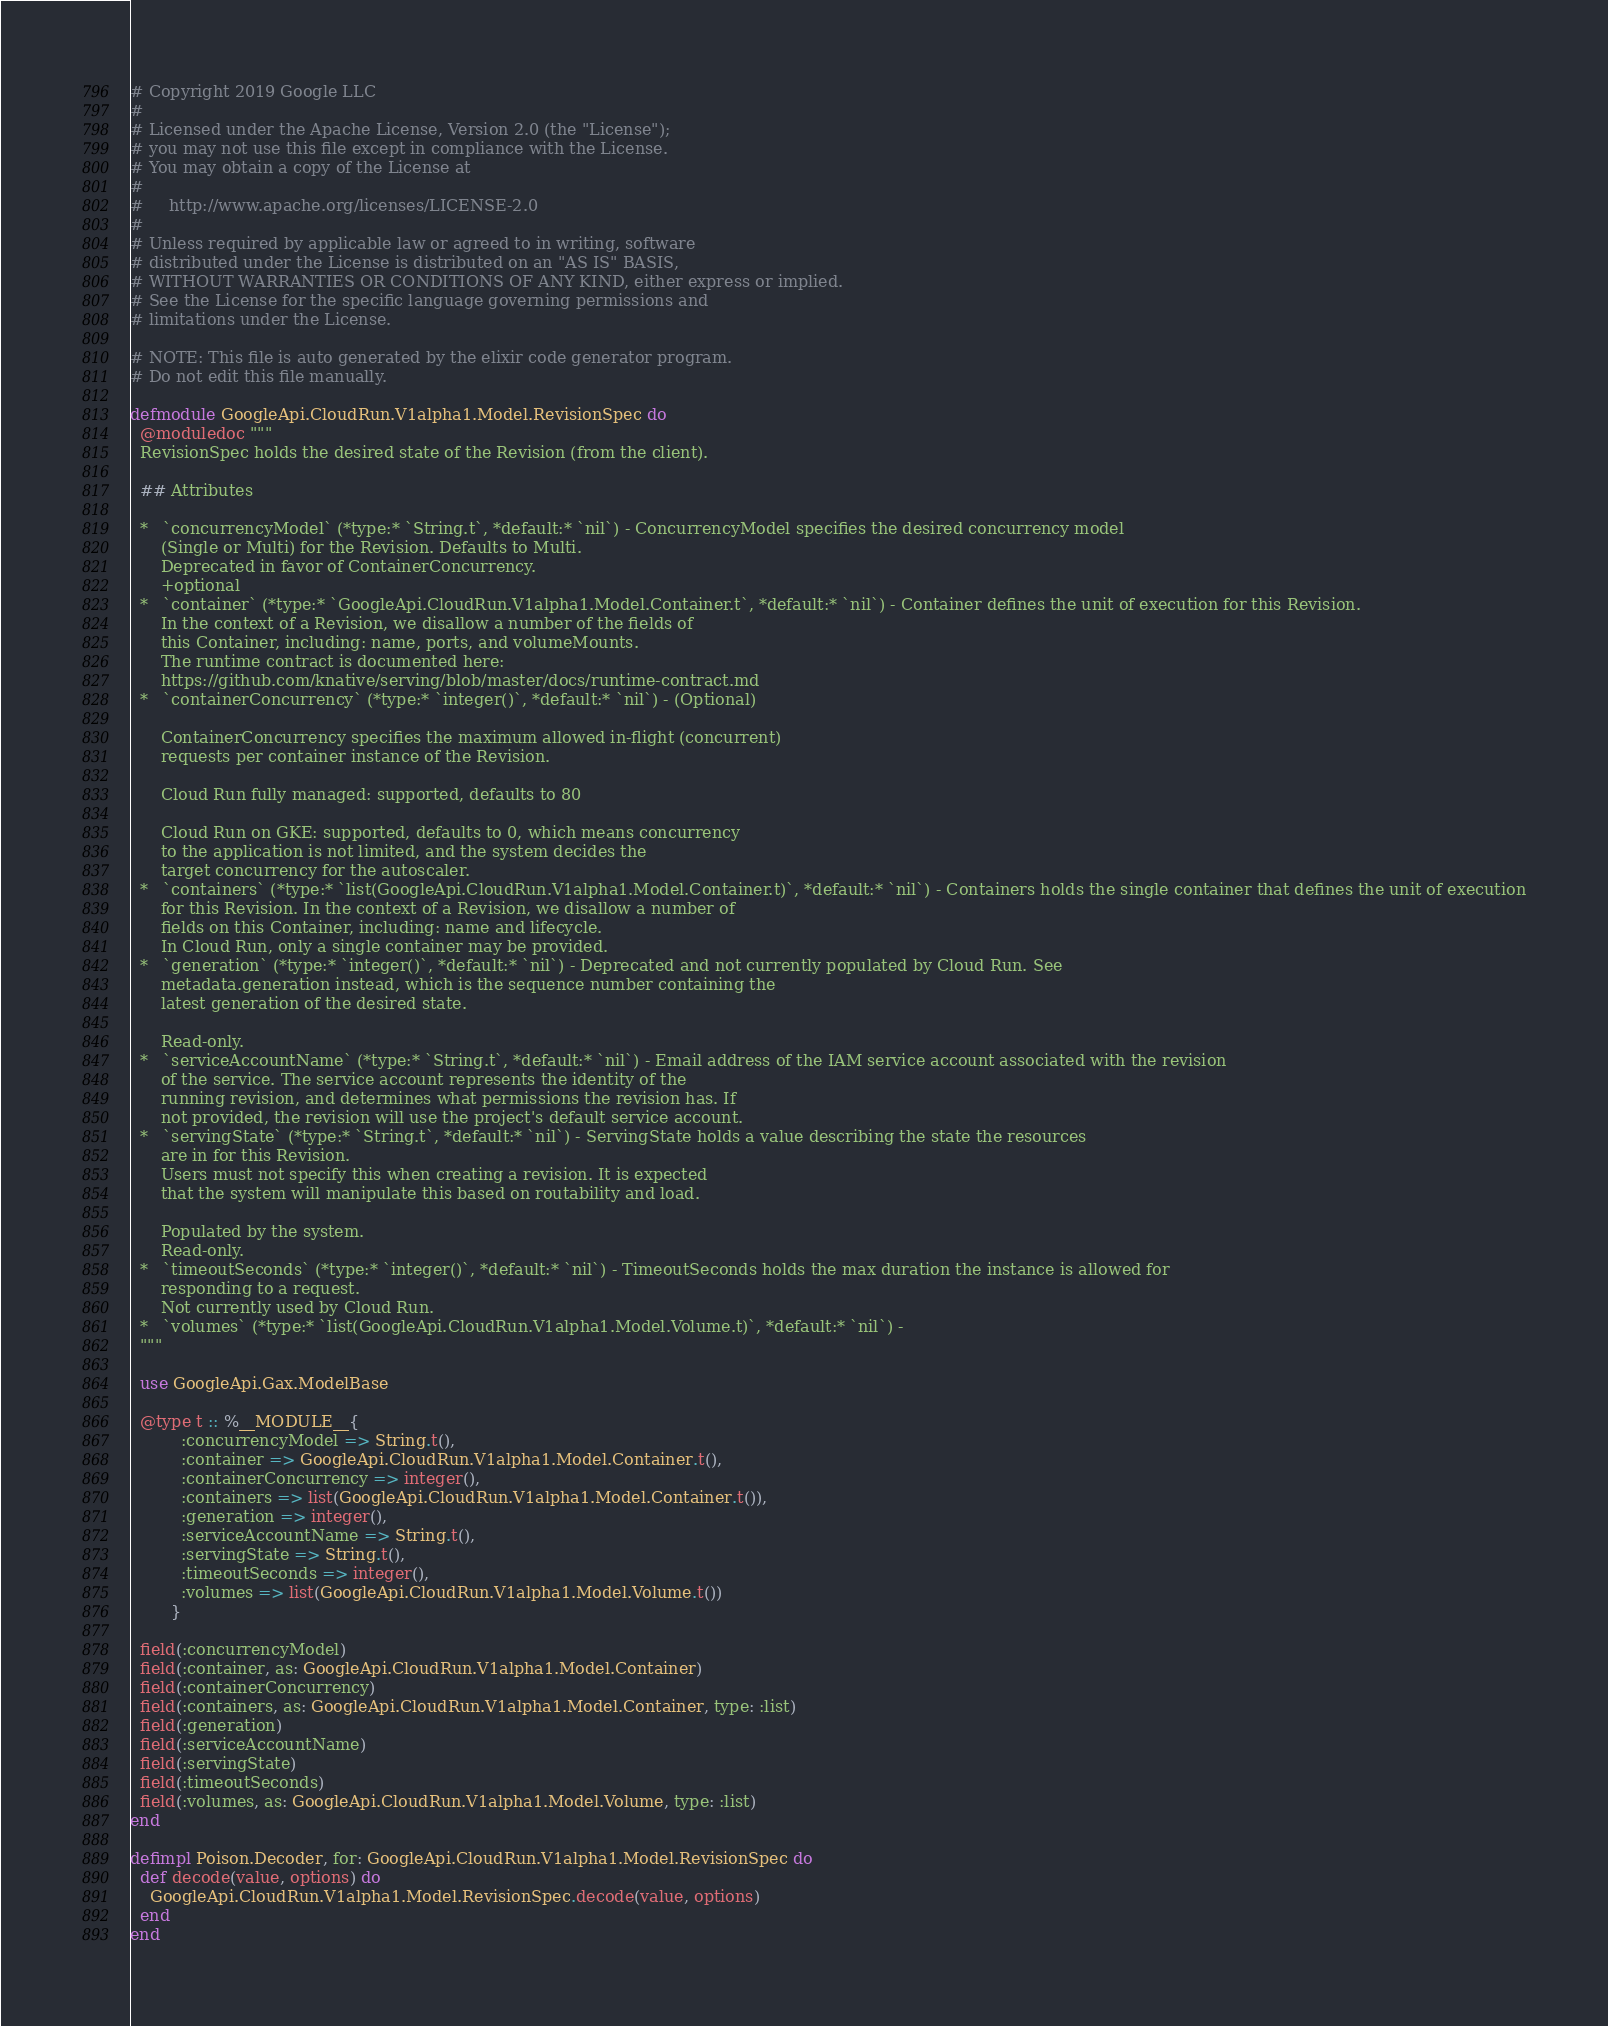Convert code to text. <code><loc_0><loc_0><loc_500><loc_500><_Elixir_># Copyright 2019 Google LLC
#
# Licensed under the Apache License, Version 2.0 (the "License");
# you may not use this file except in compliance with the License.
# You may obtain a copy of the License at
#
#     http://www.apache.org/licenses/LICENSE-2.0
#
# Unless required by applicable law or agreed to in writing, software
# distributed under the License is distributed on an "AS IS" BASIS,
# WITHOUT WARRANTIES OR CONDITIONS OF ANY KIND, either express or implied.
# See the License for the specific language governing permissions and
# limitations under the License.

# NOTE: This file is auto generated by the elixir code generator program.
# Do not edit this file manually.

defmodule GoogleApi.CloudRun.V1alpha1.Model.RevisionSpec do
  @moduledoc """
  RevisionSpec holds the desired state of the Revision (from the client).

  ## Attributes

  *   `concurrencyModel` (*type:* `String.t`, *default:* `nil`) - ConcurrencyModel specifies the desired concurrency model
      (Single or Multi) for the Revision. Defaults to Multi.
      Deprecated in favor of ContainerConcurrency.
      +optional
  *   `container` (*type:* `GoogleApi.CloudRun.V1alpha1.Model.Container.t`, *default:* `nil`) - Container defines the unit of execution for this Revision.
      In the context of a Revision, we disallow a number of the fields of
      this Container, including: name, ports, and volumeMounts.
      The runtime contract is documented here:
      https://github.com/knative/serving/blob/master/docs/runtime-contract.md
  *   `containerConcurrency` (*type:* `integer()`, *default:* `nil`) - (Optional)

      ContainerConcurrency specifies the maximum allowed in-flight (concurrent)
      requests per container instance of the Revision.

      Cloud Run fully managed: supported, defaults to 80

      Cloud Run on GKE: supported, defaults to 0, which means concurrency
      to the application is not limited, and the system decides the
      target concurrency for the autoscaler.
  *   `containers` (*type:* `list(GoogleApi.CloudRun.V1alpha1.Model.Container.t)`, *default:* `nil`) - Containers holds the single container that defines the unit of execution
      for this Revision. In the context of a Revision, we disallow a number of
      fields on this Container, including: name and lifecycle.
      In Cloud Run, only a single container may be provided.
  *   `generation` (*type:* `integer()`, *default:* `nil`) - Deprecated and not currently populated by Cloud Run. See
      metadata.generation instead, which is the sequence number containing the
      latest generation of the desired state.

      Read-only.
  *   `serviceAccountName` (*type:* `String.t`, *default:* `nil`) - Email address of the IAM service account associated with the revision
      of the service. The service account represents the identity of the
      running revision, and determines what permissions the revision has. If
      not provided, the revision will use the project's default service account.
  *   `servingState` (*type:* `String.t`, *default:* `nil`) - ServingState holds a value describing the state the resources
      are in for this Revision.
      Users must not specify this when creating a revision. It is expected
      that the system will manipulate this based on routability and load.

      Populated by the system.
      Read-only.
  *   `timeoutSeconds` (*type:* `integer()`, *default:* `nil`) - TimeoutSeconds holds the max duration the instance is allowed for
      responding to a request.
      Not currently used by Cloud Run.
  *   `volumes` (*type:* `list(GoogleApi.CloudRun.V1alpha1.Model.Volume.t)`, *default:* `nil`) - 
  """

  use GoogleApi.Gax.ModelBase

  @type t :: %__MODULE__{
          :concurrencyModel => String.t(),
          :container => GoogleApi.CloudRun.V1alpha1.Model.Container.t(),
          :containerConcurrency => integer(),
          :containers => list(GoogleApi.CloudRun.V1alpha1.Model.Container.t()),
          :generation => integer(),
          :serviceAccountName => String.t(),
          :servingState => String.t(),
          :timeoutSeconds => integer(),
          :volumes => list(GoogleApi.CloudRun.V1alpha1.Model.Volume.t())
        }

  field(:concurrencyModel)
  field(:container, as: GoogleApi.CloudRun.V1alpha1.Model.Container)
  field(:containerConcurrency)
  field(:containers, as: GoogleApi.CloudRun.V1alpha1.Model.Container, type: :list)
  field(:generation)
  field(:serviceAccountName)
  field(:servingState)
  field(:timeoutSeconds)
  field(:volumes, as: GoogleApi.CloudRun.V1alpha1.Model.Volume, type: :list)
end

defimpl Poison.Decoder, for: GoogleApi.CloudRun.V1alpha1.Model.RevisionSpec do
  def decode(value, options) do
    GoogleApi.CloudRun.V1alpha1.Model.RevisionSpec.decode(value, options)
  end
end
</code> 